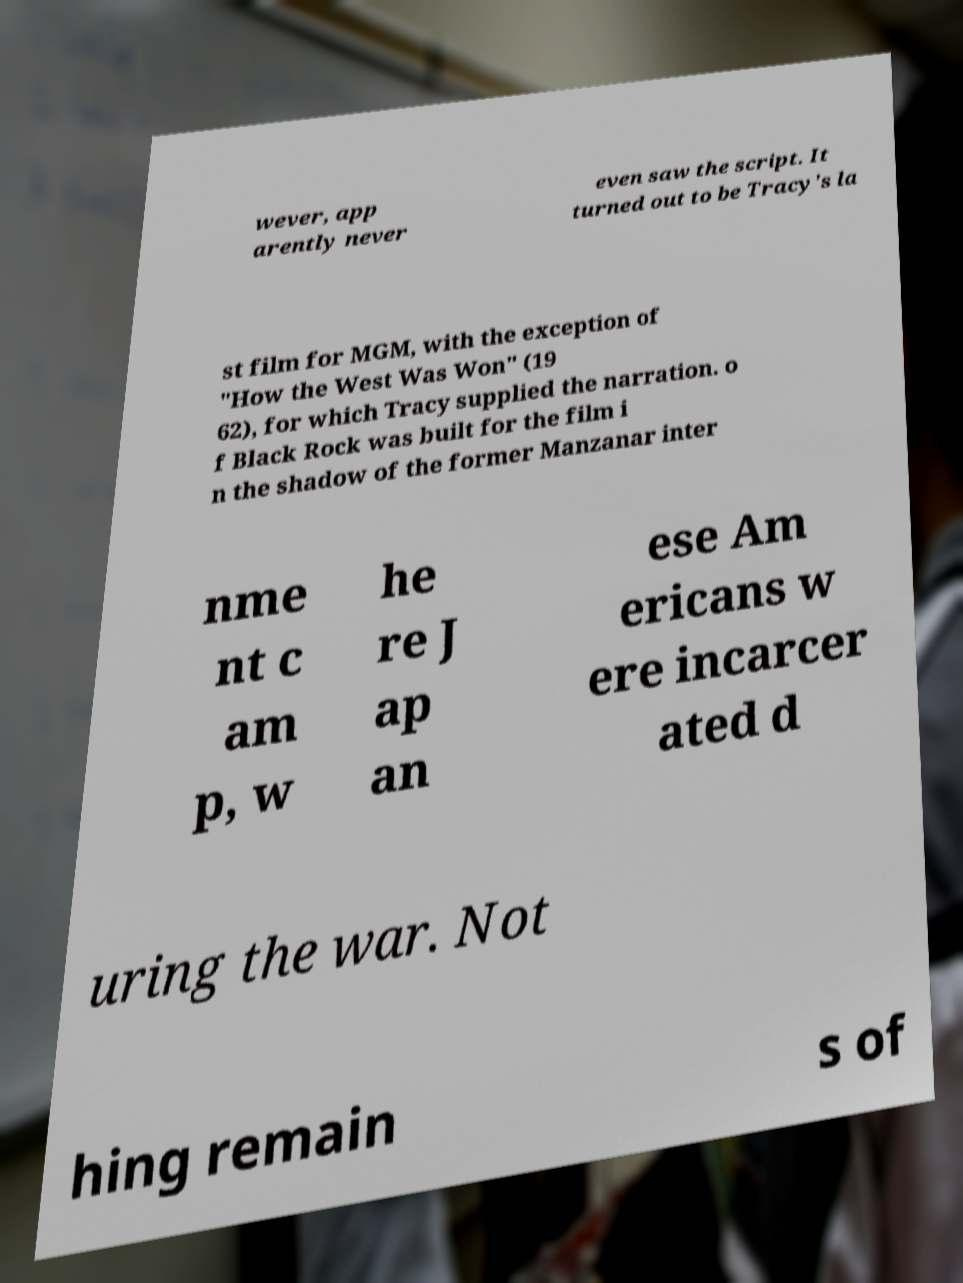Could you assist in decoding the text presented in this image and type it out clearly? wever, app arently never even saw the script. It turned out to be Tracy's la st film for MGM, with the exception of "How the West Was Won" (19 62), for which Tracy supplied the narration. o f Black Rock was built for the film i n the shadow of the former Manzanar inter nme nt c am p, w he re J ap an ese Am ericans w ere incarcer ated d uring the war. Not hing remain s of 